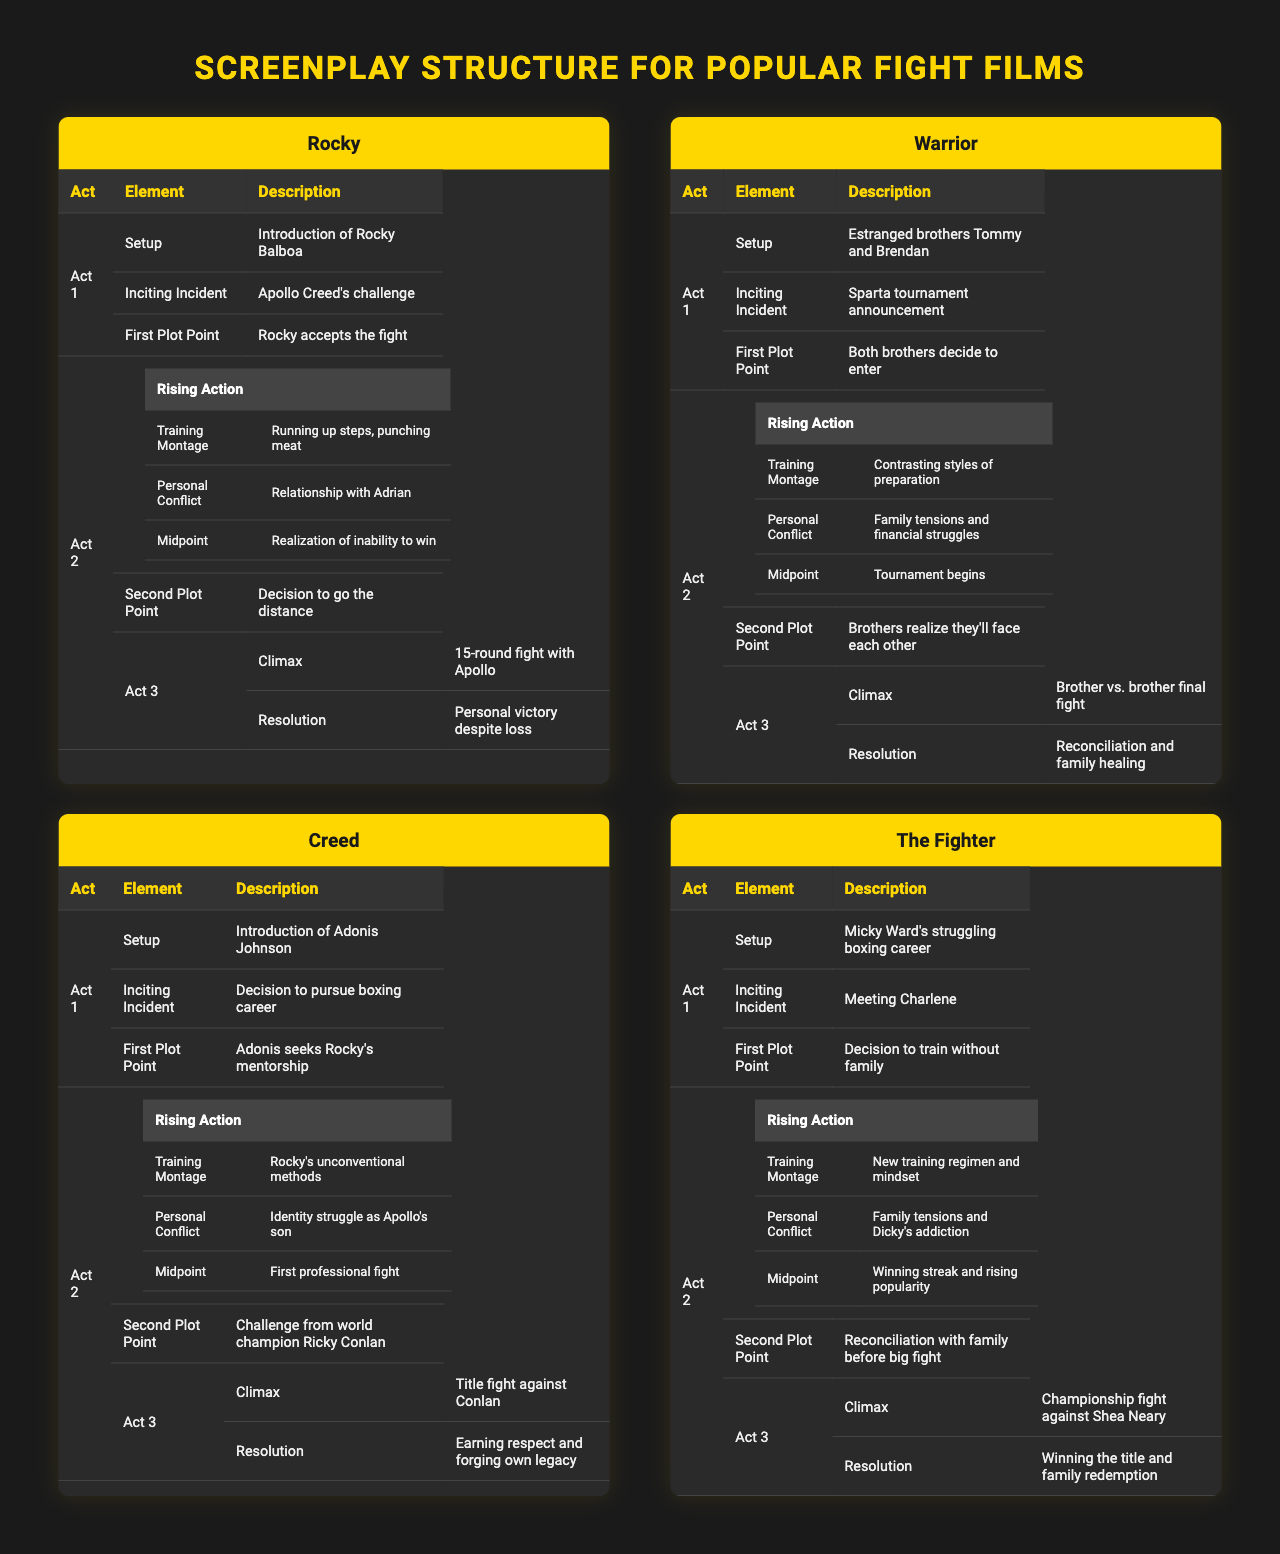What is the inciting incident for the film "Creed"? The table shows that the inciting incident for "Creed" is the decision of Adonis Johnson to pursue a boxing career.
Answer: Decision to pursue boxing career Which film features a brother vs. brother final fight in Act 3? The table indicates that "Warrior" is the film that has a brother vs. brother final fight as its climax in Act 3.
Answer: Warrior How many films have a training montage listed in Act 2? By counting the "Training Montage" entries in Act 2 across the films, we see there are four films that include a training montage: "Rocky," "Warrior," "Creed," and "The Fighter."
Answer: 4 Does "The Fighter" feature a personal conflict related to addiction? The table confirms that "The Fighter" includes a personal conflict about Dicky's addiction.
Answer: Yes What is the resolution of the film "Rocky"? According to the table, the resolution for "Rocky" is personal victory despite loss.
Answer: Personal victory despite loss What is the second plot point for "Warrior"? The table lists that the second plot point for "Warrior" is when the brothers realize they'll face each other in the tournament.
Answer: Brothers realize they'll face each other Comparing "Rocky" and "Creed," which one has a midpoint that focuses on a personal conflict? For "Rocky," the midpoint is the realization of inability to win, which relates to personal conflict; for "Creed," the midpoint is about the first professional fight, which is less about personal conflict. Thus, "Rocky" is the one that has a midpoint focusing on personal conflict.
Answer: Rocky What did Rocky accept as his first plot point? The table specifies that Rocky accepted Apollo Creed's challenge as the first plot point.
Answer: Apollo Creed's challenge List the main elements of Act 2 for "The Fighter." In the table, Act 2 of "The Fighter" includes a training montage, personal conflict about family tensions and Dicky's addiction, the midpoint of winning streak and rising popularity, and the second plot point of reconciliation with family.
Answer: Training Montage, Personal Conflict, Midpoint, Second Plot Point Which film's climax is a championship fight? The table indicates that "The Fighter" has its climax as a championship fight against Shea Neary.
Answer: The Fighter 